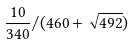Convert formula to latex. <formula><loc_0><loc_0><loc_500><loc_500>\frac { 1 0 } { 3 4 0 } / ( 4 6 0 + \sqrt { 4 9 2 } )</formula> 